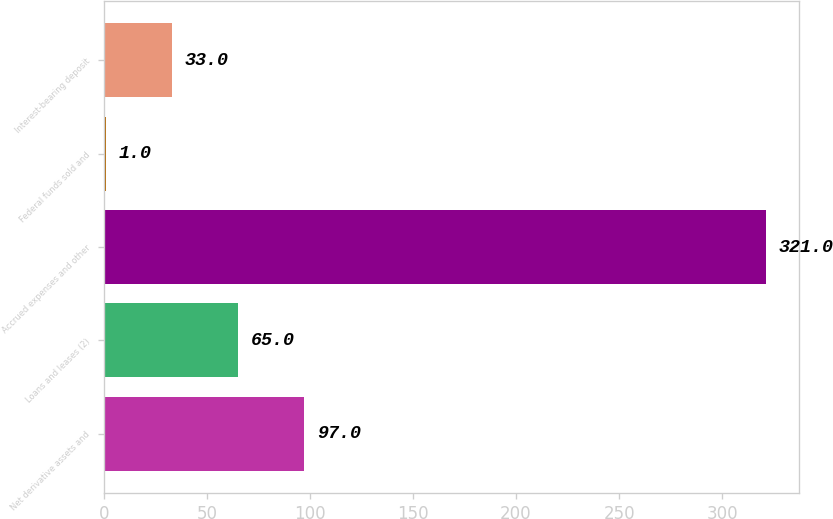Convert chart to OTSL. <chart><loc_0><loc_0><loc_500><loc_500><bar_chart><fcel>Net derivative assets and<fcel>Loans and leases (2)<fcel>Accrued expenses and other<fcel>Federal funds sold and<fcel>Interest-bearing deposit<nl><fcel>97<fcel>65<fcel>321<fcel>1<fcel>33<nl></chart> 